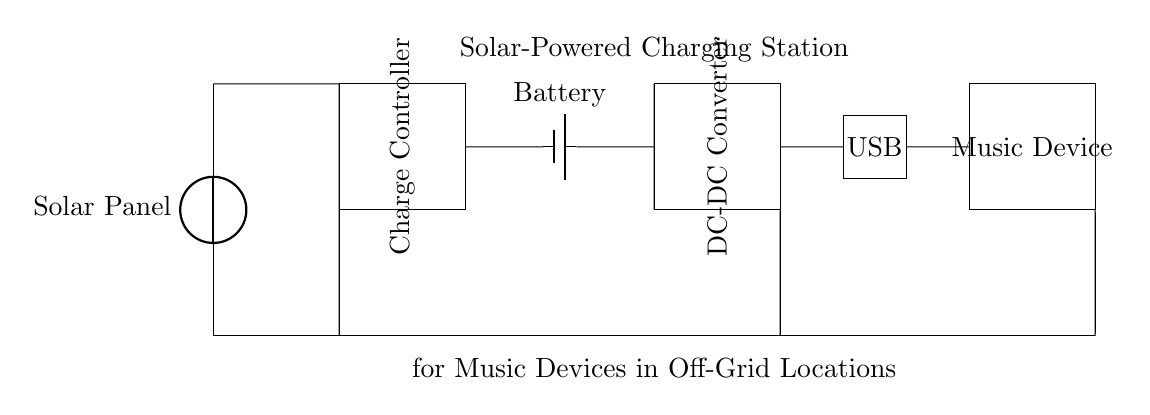What is the first component in the circuit? The first component is the Solar Panel, as it is positioned at the top of the circuit diagram and supplies power to the entire system.
Answer: Solar Panel What does the Charge Controller do? The Charge Controller regulates the voltage and current from the Solar Panel before charging the Battery, thus preventing overcharging and damage to the Battery.
Answer: Regulates charging How many output devices are connected to the circuit? There is one output device, which is the Music Device, connected to the USB port in the circuit.
Answer: One What is the purpose of the DC-DC Converter? The DC-DC Converter takes the specific voltage output from the Battery and adjusts it to the required level for the USB port, ensuring compatibility with the Music Device.
Answer: Adjust voltage Which components are connected in series in the circuit? The Solar Panel, Charge Controller, Battery, DC-DC Converter, and USB Port are all connected in series, forming a single path for current flow.
Answer: All components What type of circuit is shown in the diagram? The circuit shown is a series circuit, as there is only one path for the current to flow through all components sequentially.
Answer: Series circuit What component acts as a power source in the diagram? The Solar Panel acts as the power source, converting sunlight into electrical energy for the system.
Answer: Solar Panel 